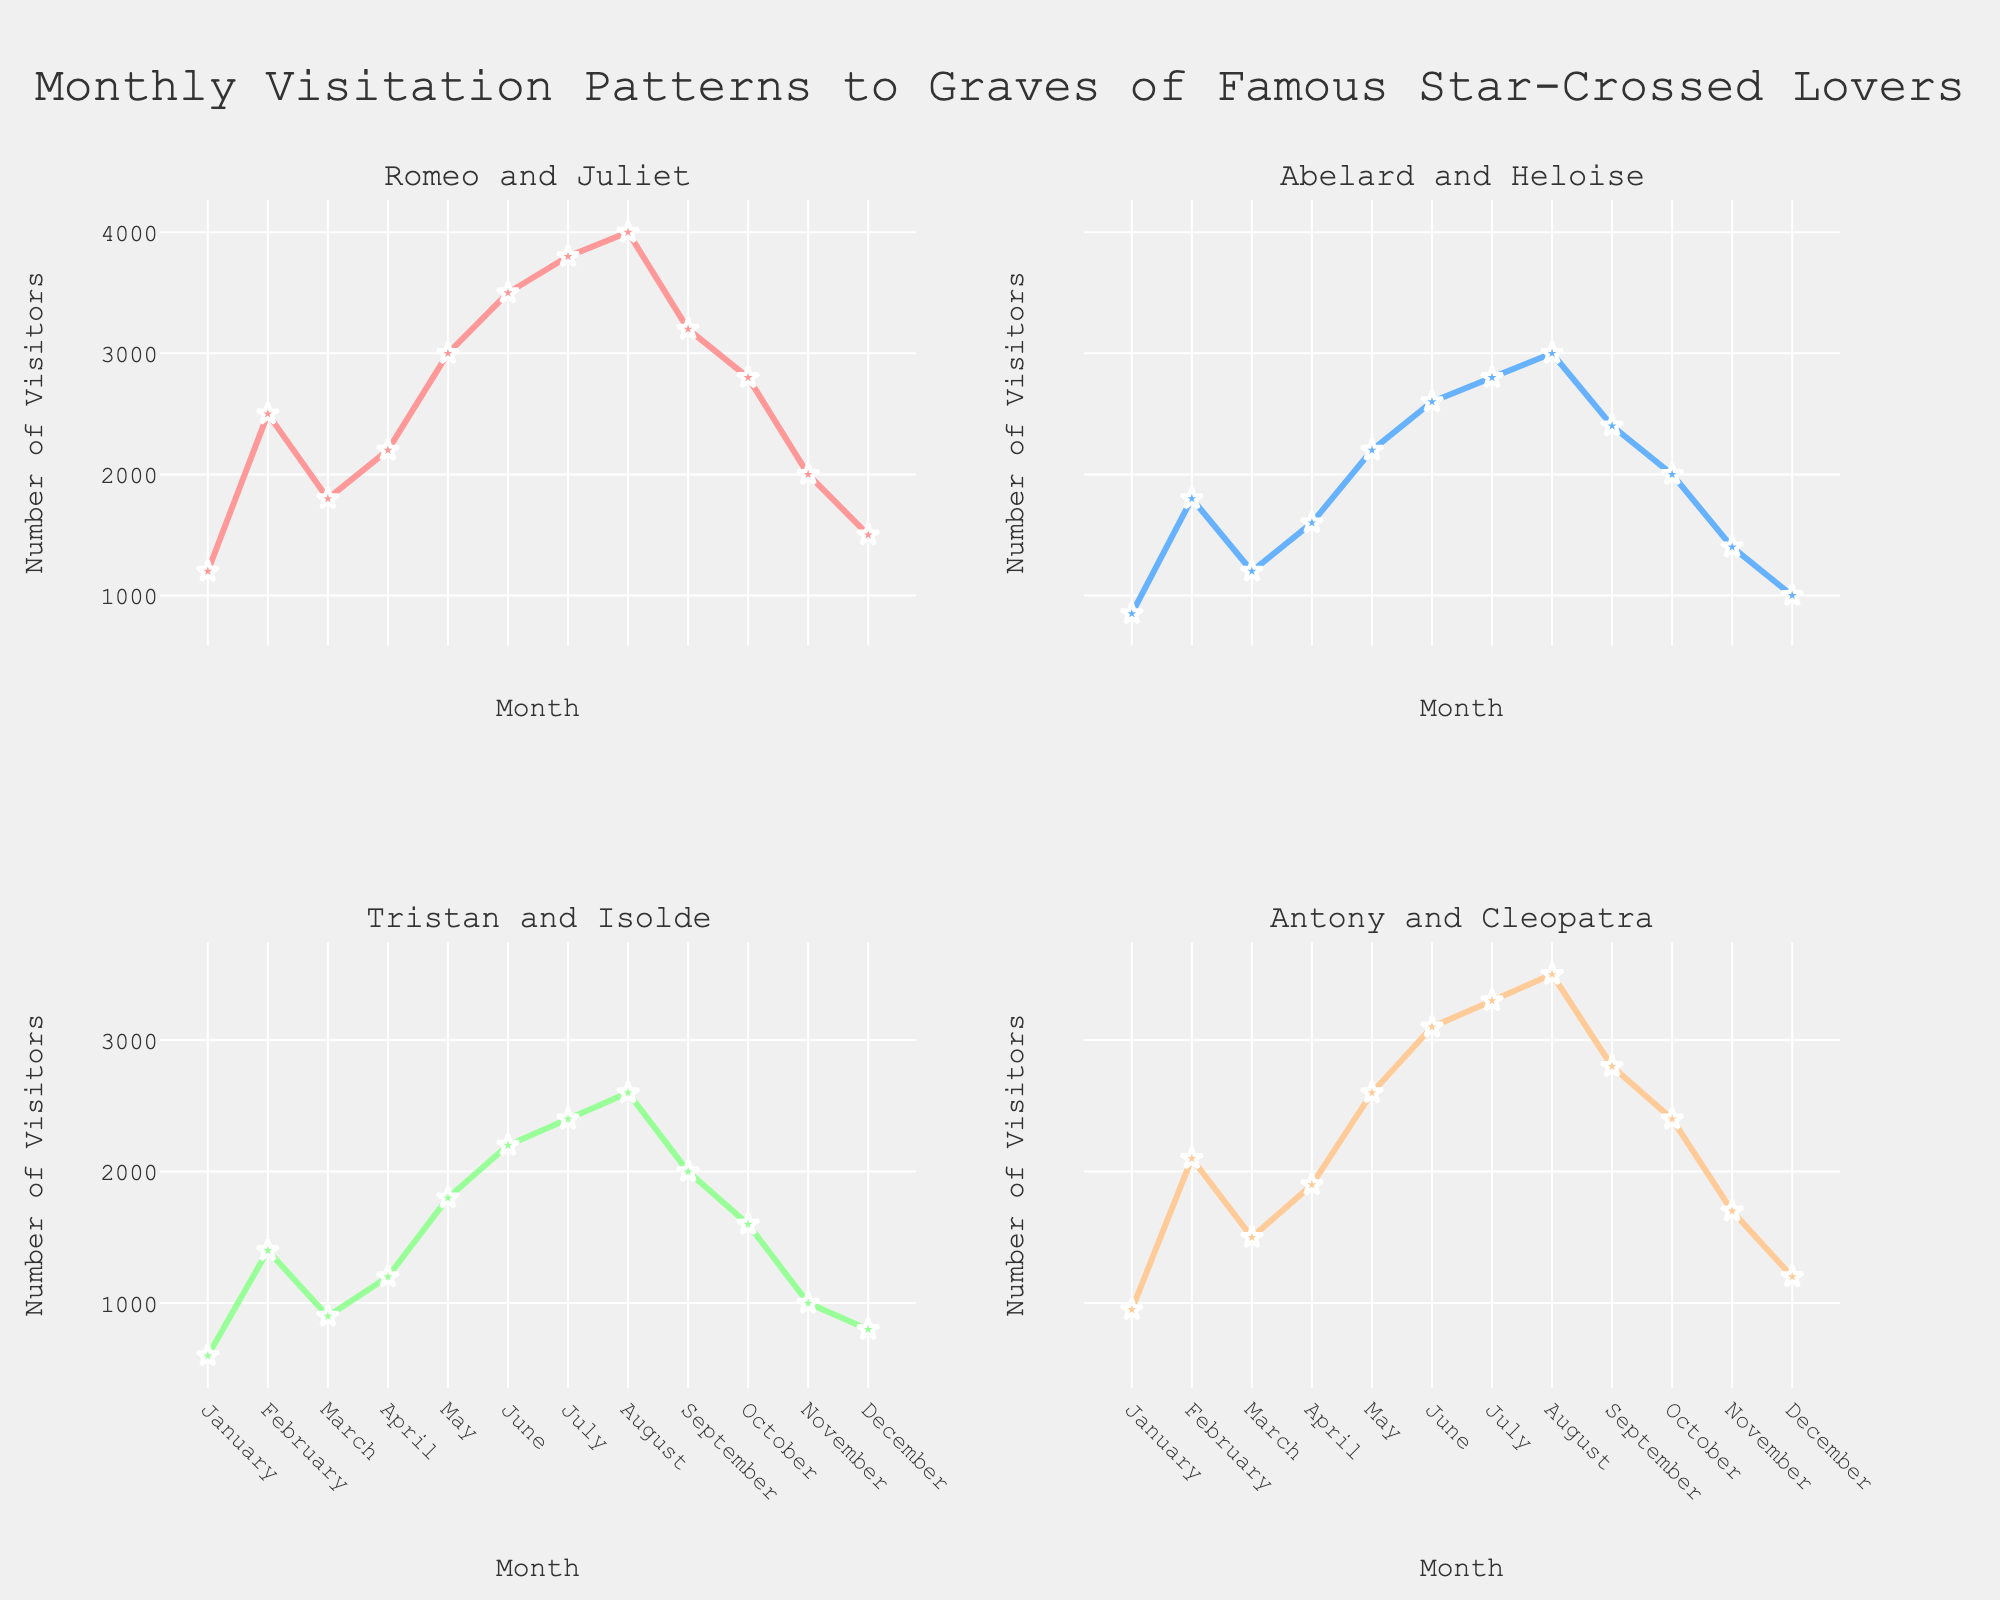What year did the 'Improved Break Areas' initiative have the lowest success rate? To determine the lowest success rate for the 'Improved Break Areas' initiative, look at the 'Success Rate' subplot and identify the year with the minimum value for this initiative line. In 2018, the success rate is 62, which is the lowest.
Answer: 2018 Which initiative had the highest employee satisfaction in 2021? To find the initiative with the highest employee satisfaction in 2021, refer to the 'Employee Satisfaction' subplot and look at the value points for 2021. 'Flexible Work Hours' had a satisfaction rate of 92, which is the highest.
Answer: Flexible Work Hours What was the overall trend for employee satisfaction from 2018 to 2021? To understand the trend for overall employee satisfaction, check the 'Overall Trend' subplot and observe the plotted line for 'Employee Satisfaction'. The employee satisfaction increased from around 75 in 2018 to close to 85 in 2021.
Answer: Increasing How did 'Team Building Workshops' impact productivity over the years? To examine the impact of 'Team Building Workshops' on productivity, observe the 'Productivity Increase' subplot. The values for 'Team Building Workshops' improve incrementally from 5 in 2018 to 8 in 2021.
Answer: Positive trend Compare the success rate of 'Flexible Work Hours' in 2018 and 2021. Look at the 'Success Rate' subplot and find the values for 'Flexible Work Hours' in both years. The success rate increased from 78 in 2018 to 88 in 2021.
Answer: Increased by 10 Which initiative showed the most improvement in success rate from 2018 to 2021? To find the initiative with the most improvement, compute the difference in success rate from 2018 to 2021 for each. 'Employee Recognition Program' improved by 13 (from 70 to 83), the largest increase.
Answer: Employee Recognition Program What was the productivity increase for the 'Improved Break Areas' initiative in 2019? Refer to the 'Productivity Increase' subplot and check the value for the 'Improved Break Areas' initiative in 2019. The productivity increase was 4.
Answer: 4 Is there a correlation between employee satisfaction and productivity increase over the years? To determine the correlation, observe the 'Overall Trend' subplot where both 'Employee Satisfaction' and 'Productivity Increase' are plotted. Both metrics show an increasing trend from 2018 to 2021, suggesting a positive correlation.
Answer: Yes, positive correlation 